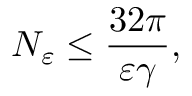<formula> <loc_0><loc_0><loc_500><loc_500>N _ { \varepsilon } \leq \frac { 3 2 \pi } { \varepsilon \gamma } ,</formula> 